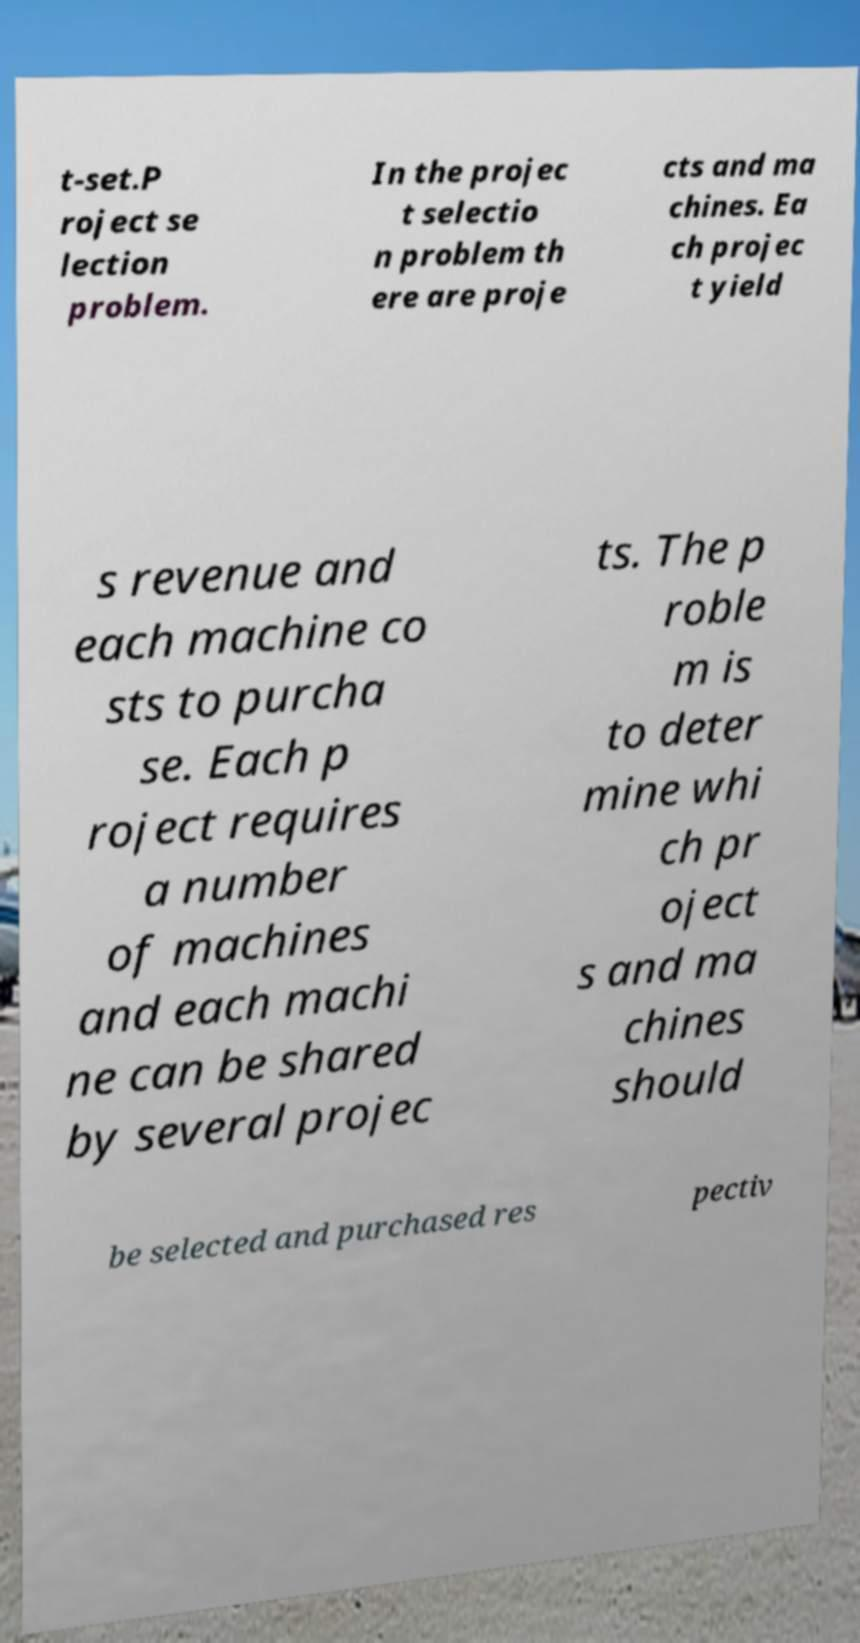Please identify and transcribe the text found in this image. t-set.P roject se lection problem. In the projec t selectio n problem th ere are proje cts and ma chines. Ea ch projec t yield s revenue and each machine co sts to purcha se. Each p roject requires a number of machines and each machi ne can be shared by several projec ts. The p roble m is to deter mine whi ch pr oject s and ma chines should be selected and purchased res pectiv 